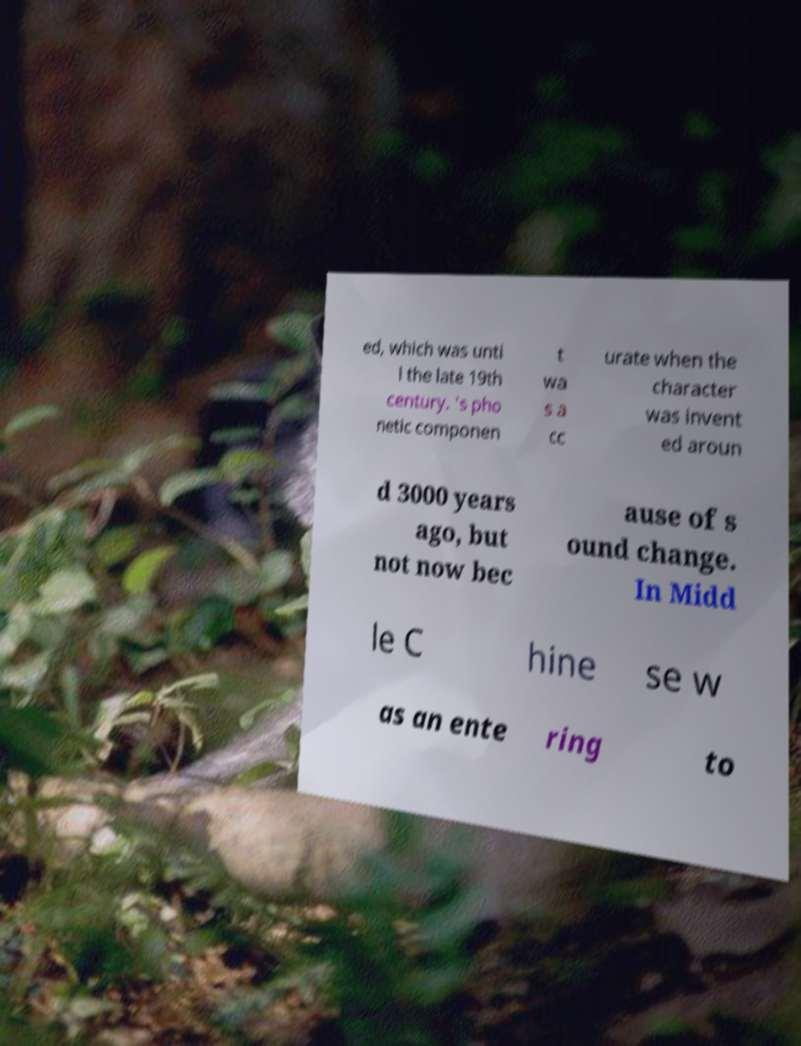Can you accurately transcribe the text from the provided image for me? ed, which was unti l the late 19th century. 's pho netic componen t wa s a cc urate when the character was invent ed aroun d 3000 years ago, but not now bec ause of s ound change. In Midd le C hine se w as an ente ring to 